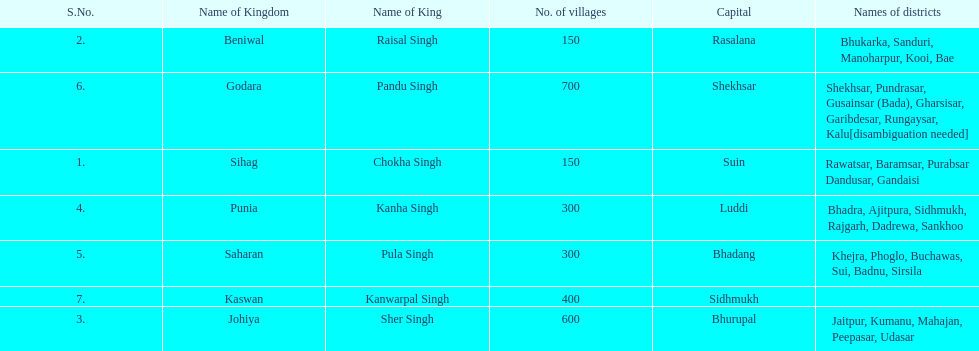What are the number of villages johiya has according to this chart? 600. 